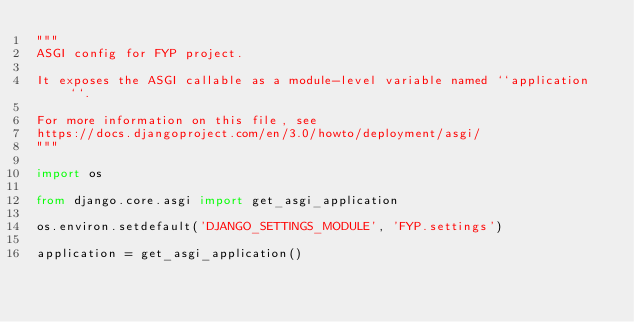Convert code to text. <code><loc_0><loc_0><loc_500><loc_500><_Python_>"""
ASGI config for FYP project.

It exposes the ASGI callable as a module-level variable named ``application``.

For more information on this file, see
https://docs.djangoproject.com/en/3.0/howto/deployment/asgi/
"""

import os

from django.core.asgi import get_asgi_application

os.environ.setdefault('DJANGO_SETTINGS_MODULE', 'FYP.settings')

application = get_asgi_application()
</code> 